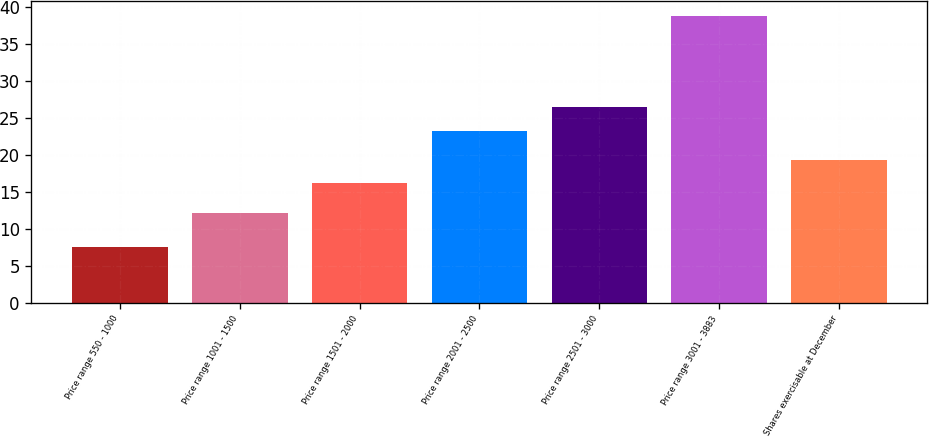Convert chart to OTSL. <chart><loc_0><loc_0><loc_500><loc_500><bar_chart><fcel>Price range 550 - 1000<fcel>Price range 1001 - 1500<fcel>Price range 1501 - 2000<fcel>Price range 2001 - 2500<fcel>Price range 2501 - 3000<fcel>Price range 3001 - 3883<fcel>Shares exercisable at December<nl><fcel>7.55<fcel>12.12<fcel>16.21<fcel>23.29<fcel>26.45<fcel>38.83<fcel>19.34<nl></chart> 